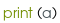Convert code to text. <code><loc_0><loc_0><loc_500><loc_500><_Python_>print (a)</code> 